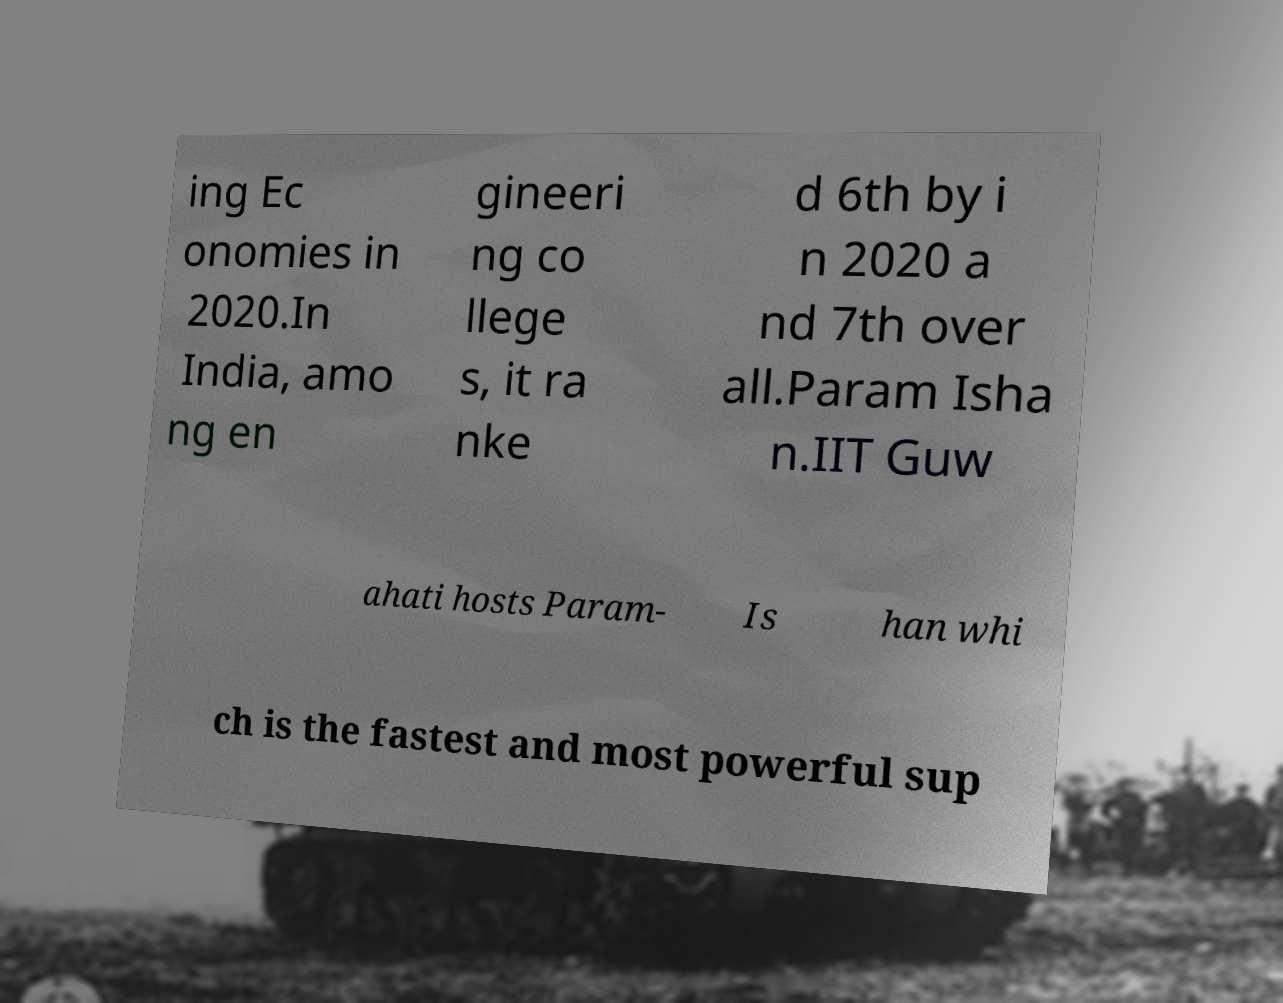I need the written content from this picture converted into text. Can you do that? ing Ec onomies in 2020.In India, amo ng en gineeri ng co llege s, it ra nke d 6th by i n 2020 a nd 7th over all.Param Isha n.IIT Guw ahati hosts Param- Is han whi ch is the fastest and most powerful sup 